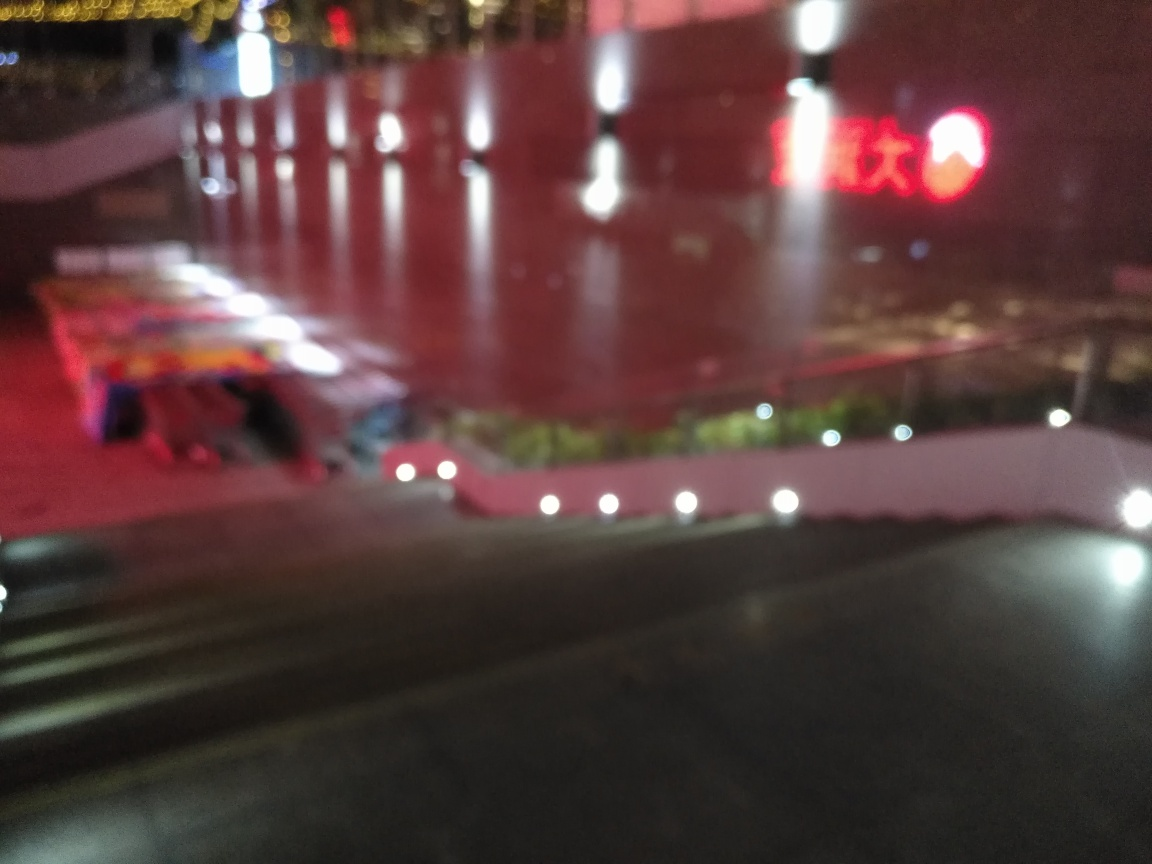Can you describe the overall composition and elements present in this image? The image features a nighttime urban scene with artificial lighting. The focus is soft, creating a blurred effect. Visible elements include light reflections on a wet surface, suggesting recent rain, and illuminated signs that are not sharp enough to read. The color palette is dominated by warm tones. Does this image seem to be taken during a special event or a regular night? Given the wet surfaces and the blurred light reflections, it is difficult to ascertain whether a special event was occurring. The lack of sharpness and definition in the image, along with no visible crowds or decorations, leans towards the representation of a regular night rather than a special occasion. 